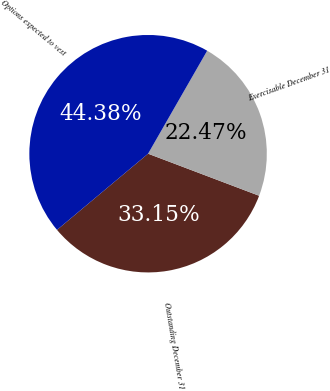Convert chart. <chart><loc_0><loc_0><loc_500><loc_500><pie_chart><fcel>Outstanding December 31<fcel>Exercisable December 31<fcel>Options expected to vest<nl><fcel>33.15%<fcel>22.47%<fcel>44.38%<nl></chart> 